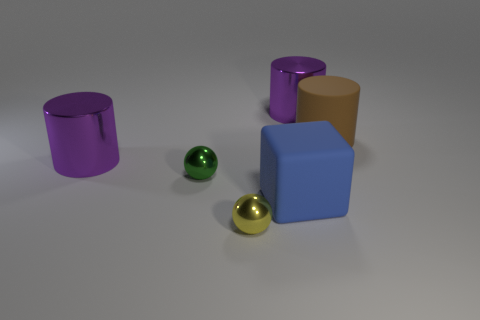What is the material of the small yellow thing?
Offer a terse response. Metal. Is the size of the ball in front of the green metallic ball the same as the green thing?
Offer a very short reply. Yes. There is a purple object to the right of the green sphere; what is its size?
Offer a very short reply. Large. What number of rubber cylinders are there?
Make the answer very short. 1. What is the color of the metallic thing that is both right of the green ball and behind the large blue rubber block?
Keep it short and to the point. Purple. There is a brown object; are there any big metal things in front of it?
Ensure brevity in your answer.  Yes. There is a large rubber thing that is in front of the brown object; how many large blocks are on the left side of it?
Make the answer very short. 0. There is a yellow ball that is made of the same material as the small green sphere; what size is it?
Your response must be concise. Small. The block has what size?
Give a very brief answer. Large. Do the yellow sphere and the blue cube have the same material?
Keep it short and to the point. No. 